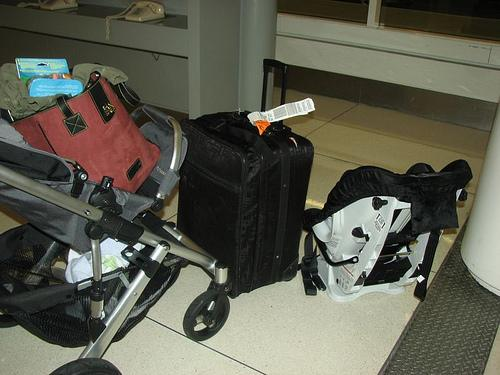Describe the image using short phrases or keywords. Black luggage, grey baby stroller, cluttered items, maroon red bag, black and white car seat, beige corded telephones, white floor tiles. Write a brief and concise description of the objects and colors visible in the image. The image displays various objects like a black luggage, grey stroller with clutter, maroon red bag, black and white car seat, and beige telephones on a counter, all set on a white and brown tiled floor. Mention the primary objects and their colors displayed in the photograph. The image displays a black luggage, a grey baby stroller, a black and white car seat, maroon red bag, white floor tiles, and beige corded telephones. Describe the main elements in the photograph by focusing on their colors and positions. The image features a black luggage on the floor, a grey cluttered baby stroller, a black and white car seat, a maroon red bag on the stroller, white floor tiles, and beige corded telephones on a counter. Quickly summarize the key components of the image and the colors present. The image showcases a black luggage, a grey cluttered stroller, a black and white car seat, a maroon red bag, beige corded telephones, and white floor tiles. Create a description of the scene in the image using an active voice. A black luggage with a handle sits on the floor next to a grey baby stroller filled with stuff and a black and white car seat, while a maroon red bag lies on the stroller near two beige corded telephones on a counter with a white and brown tiled floor. Use a passive voice to describe what can be seen in this image. A black luggage with a handle, a grey baby stroller with clutter, and a black and white car seat can be seen lying on the floor, while a maroon red bag is placed on the stroller and two beige corded telephones are set on a shelf near a tiled floor that's partially white. Compose a sentence that summarizes the content of the image. The image contains various objects like a black luggage, grey stroller with items, a maroon red bag, a black and white car seat, and beige telephones on a counter with white and brown floor tiles. What are the main items seen in this picture and what colors do they have? Main items are a solid black luggage, a grey baby stroller filled with items, a black and white car seat, maroon red bag, white floor tiles, and beige corded telephones. Pick the main objects in the image and briefly describe their appearances and positions. There is a solid black luggage on the floor, a grey baby stroller filled with items, black and white car seat, maroon red bag on stroller, two beige corded telephones on the counter, and white floor tiles. 